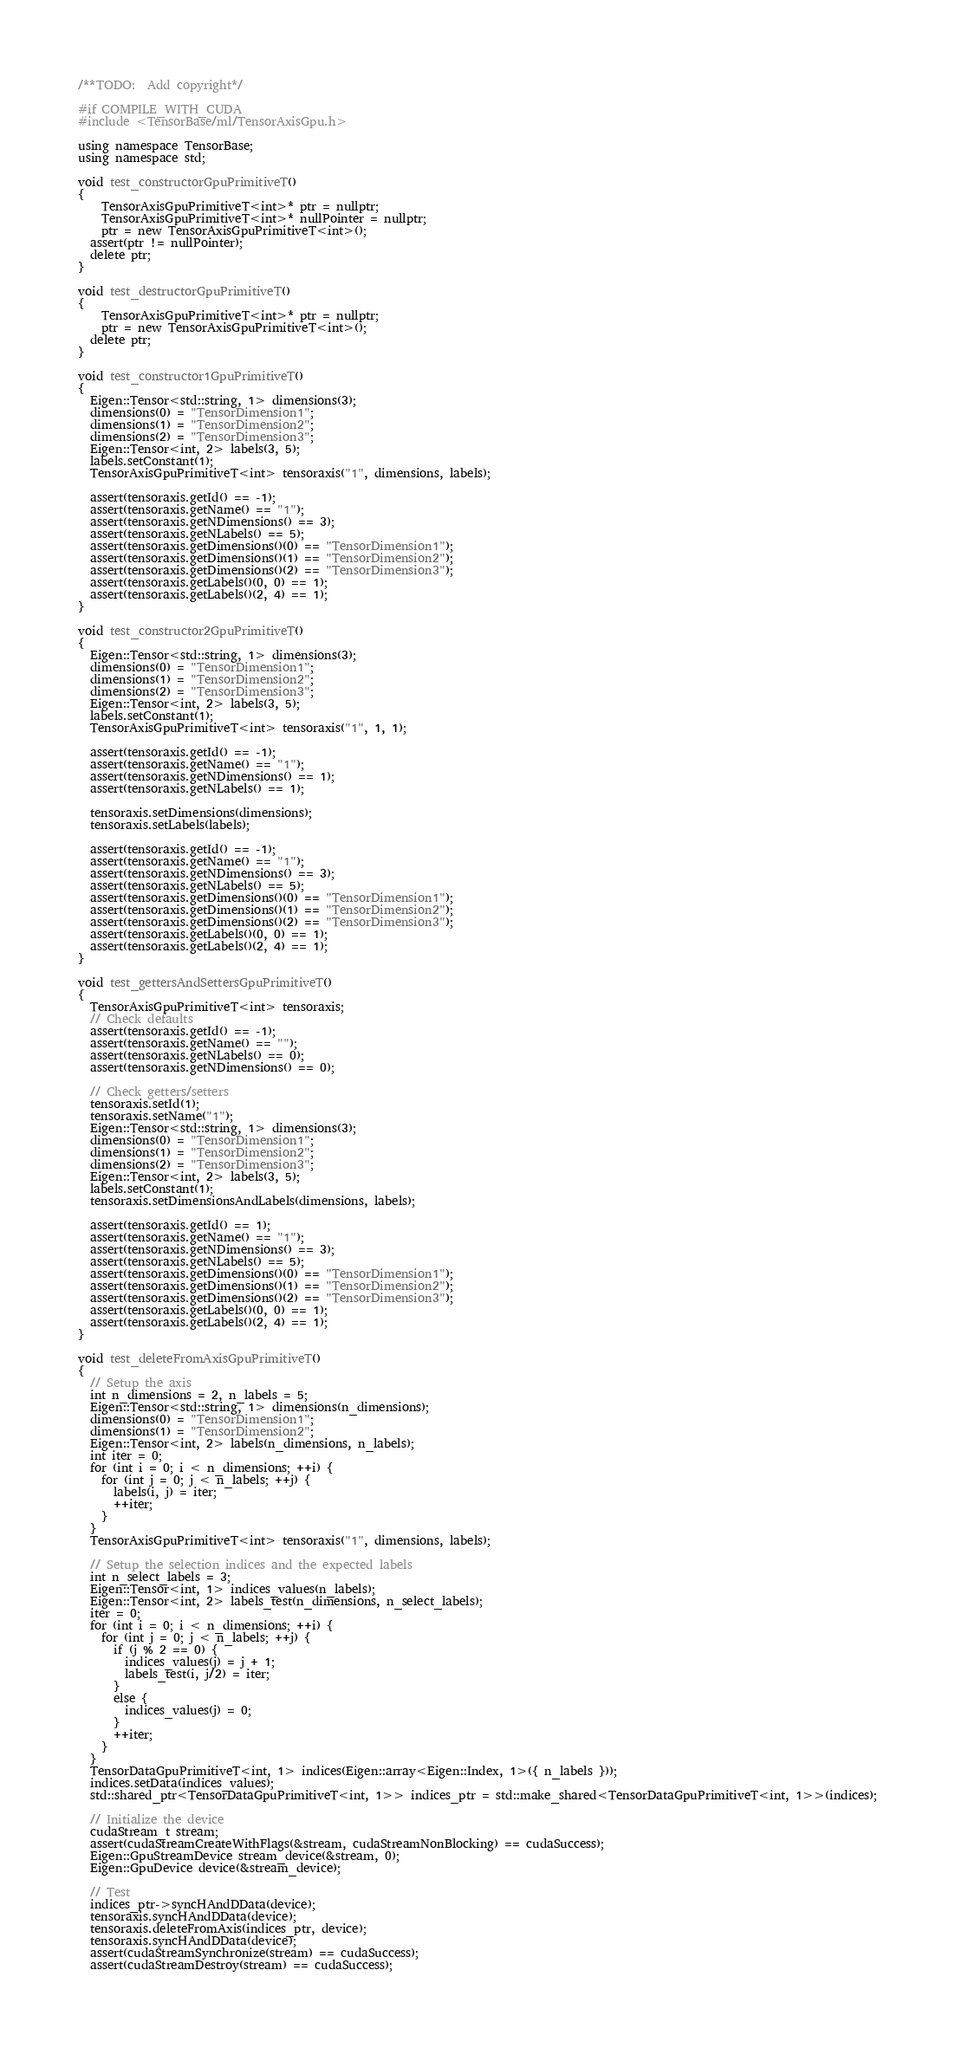Convert code to text. <code><loc_0><loc_0><loc_500><loc_500><_Cuda_>/**TODO:  Add copyright*/

#if COMPILE_WITH_CUDA
#include <TensorBase/ml/TensorAxisGpu.h>

using namespace TensorBase;
using namespace std;

void test_constructorGpuPrimitiveT() 
{
	TensorAxisGpuPrimitiveT<int>* ptr = nullptr;
	TensorAxisGpuPrimitiveT<int>* nullPointer = nullptr;
	ptr = new TensorAxisGpuPrimitiveT<int>();
  assert(ptr != nullPointer);
  delete ptr;
}

void test_destructorGpuPrimitiveT()
{
	TensorAxisGpuPrimitiveT<int>* ptr = nullptr;
	ptr = new TensorAxisGpuPrimitiveT<int>();
  delete ptr;
}

void test_constructor1GpuPrimitiveT()
{
  Eigen::Tensor<std::string, 1> dimensions(3);
  dimensions(0) = "TensorDimension1";
  dimensions(1) = "TensorDimension2";
  dimensions(2) = "TensorDimension3";
  Eigen::Tensor<int, 2> labels(3, 5);
  labels.setConstant(1);
  TensorAxisGpuPrimitiveT<int> tensoraxis("1", dimensions, labels);

  assert(tensoraxis.getId() == -1);
  assert(tensoraxis.getName() == "1");
  assert(tensoraxis.getNDimensions() == 3);
  assert(tensoraxis.getNLabels() == 5);
  assert(tensoraxis.getDimensions()(0) == "TensorDimension1");
  assert(tensoraxis.getDimensions()(1) == "TensorDimension2");
  assert(tensoraxis.getDimensions()(2) == "TensorDimension3");
  assert(tensoraxis.getLabels()(0, 0) == 1);
  assert(tensoraxis.getLabels()(2, 4) == 1);
}

void test_constructor2GpuPrimitiveT()
{
  Eigen::Tensor<std::string, 1> dimensions(3);
  dimensions(0) = "TensorDimension1";
  dimensions(1) = "TensorDimension2";
  dimensions(2) = "TensorDimension3";
  Eigen::Tensor<int, 2> labels(3, 5);
  labels.setConstant(1);
  TensorAxisGpuPrimitiveT<int> tensoraxis("1", 1, 1);

  assert(tensoraxis.getId() == -1);
  assert(tensoraxis.getName() == "1");
  assert(tensoraxis.getNDimensions() == 1);
  assert(tensoraxis.getNLabels() == 1);

  tensoraxis.setDimensions(dimensions);
  tensoraxis.setLabels(labels);

  assert(tensoraxis.getId() == -1);
  assert(tensoraxis.getName() == "1");
  assert(tensoraxis.getNDimensions() == 3);
  assert(tensoraxis.getNLabels() == 5);
  assert(tensoraxis.getDimensions()(0) == "TensorDimension1");
  assert(tensoraxis.getDimensions()(1) == "TensorDimension2");
  assert(tensoraxis.getDimensions()(2) == "TensorDimension3");
  assert(tensoraxis.getLabels()(0, 0) == 1);
  assert(tensoraxis.getLabels()(2, 4) == 1);
}

void test_gettersAndSettersGpuPrimitiveT()
{
  TensorAxisGpuPrimitiveT<int> tensoraxis;
  // Check defaults
  assert(tensoraxis.getId() == -1);
  assert(tensoraxis.getName() == "");
  assert(tensoraxis.getNLabels() == 0);
  assert(tensoraxis.getNDimensions() == 0);

  // Check getters/setters
  tensoraxis.setId(1);
  tensoraxis.setName("1");
  Eigen::Tensor<std::string, 1> dimensions(3);
  dimensions(0) = "TensorDimension1";
  dimensions(1) = "TensorDimension2";
  dimensions(2) = "TensorDimension3";
  Eigen::Tensor<int, 2> labels(3, 5);
  labels.setConstant(1);
  tensoraxis.setDimensionsAndLabels(dimensions, labels);

  assert(tensoraxis.getId() == 1);
  assert(tensoraxis.getName() == "1");
  assert(tensoraxis.getNDimensions() == 3);
  assert(tensoraxis.getNLabels() == 5);
  assert(tensoraxis.getDimensions()(0) == "TensorDimension1");
  assert(tensoraxis.getDimensions()(1) == "TensorDimension2");
  assert(tensoraxis.getDimensions()(2) == "TensorDimension3");
  assert(tensoraxis.getLabels()(0, 0) == 1);
  assert(tensoraxis.getLabels()(2, 4) == 1);
}

void test_deleteFromAxisGpuPrimitiveT()
{
  // Setup the axis
  int n_dimensions = 2, n_labels = 5;
  Eigen::Tensor<std::string, 1> dimensions(n_dimensions);
  dimensions(0) = "TensorDimension1";
  dimensions(1) = "TensorDimension2";
  Eigen::Tensor<int, 2> labels(n_dimensions, n_labels);
  int iter = 0;
  for (int i = 0; i < n_dimensions; ++i) {
    for (int j = 0; j < n_labels; ++j) {
      labels(i, j) = iter;
      ++iter;
    }
  }
  TensorAxisGpuPrimitiveT<int> tensoraxis("1", dimensions, labels);

  // Setup the selection indices and the expected labels
  int n_select_labels = 3;
  Eigen::Tensor<int, 1> indices_values(n_labels);
  Eigen::Tensor<int, 2> labels_test(n_dimensions, n_select_labels);
  iter = 0;
  for (int i = 0; i < n_dimensions; ++i) {
    for (int j = 0; j < n_labels; ++j) {
      if (j % 2 == 0) {
        indices_values(j) = j + 1;
        labels_test(i, j/2) = iter;
      }
      else {
        indices_values(j) = 0;
      }
      ++iter;
    }
  }
  TensorDataGpuPrimitiveT<int, 1> indices(Eigen::array<Eigen::Index, 1>({ n_labels }));
  indices.setData(indices_values);
  std::shared_ptr<TensorDataGpuPrimitiveT<int, 1>> indices_ptr = std::make_shared<TensorDataGpuPrimitiveT<int, 1>>(indices);

  // Initialize the device
  cudaStream_t stream;
  assert(cudaStreamCreateWithFlags(&stream, cudaStreamNonBlocking) == cudaSuccess);
  Eigen::GpuStreamDevice stream_device(&stream, 0);
  Eigen::GpuDevice device(&stream_device);

  // Test
  indices_ptr->syncHAndDData(device);
  tensoraxis.syncHAndDData(device);
  tensoraxis.deleteFromAxis(indices_ptr, device);
  tensoraxis.syncHAndDData(device);
  assert(cudaStreamSynchronize(stream) == cudaSuccess);
  assert(cudaStreamDestroy(stream) == cudaSuccess);
</code> 